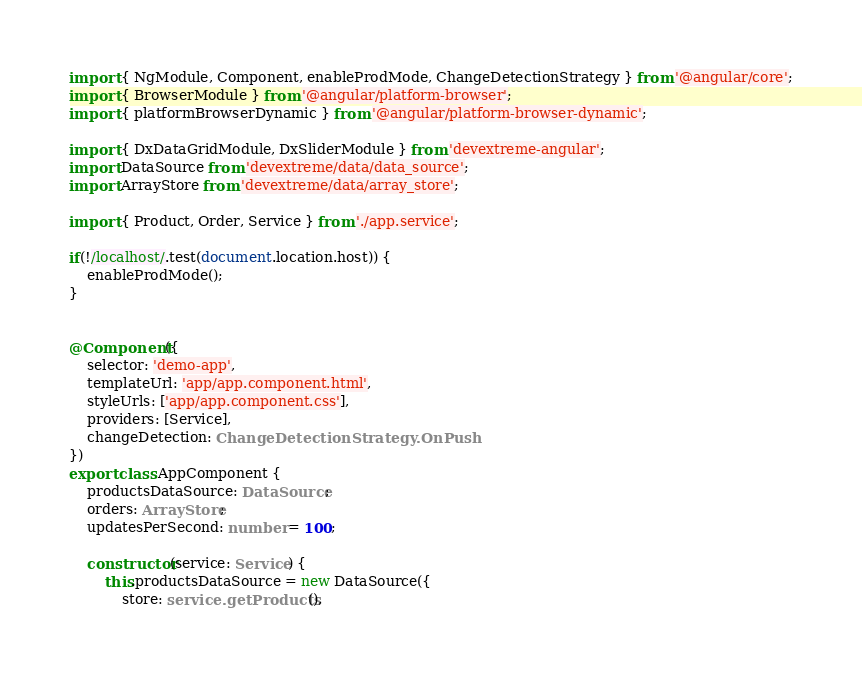Convert code to text. <code><loc_0><loc_0><loc_500><loc_500><_TypeScript_>import { NgModule, Component, enableProdMode, ChangeDetectionStrategy } from '@angular/core';
import { BrowserModule } from '@angular/platform-browser';
import { platformBrowserDynamic } from '@angular/platform-browser-dynamic';

import { DxDataGridModule, DxSliderModule } from 'devextreme-angular';
import DataSource from 'devextreme/data/data_source';
import ArrayStore from 'devextreme/data/array_store';

import { Product, Order, Service } from './app.service';

if(!/localhost/.test(document.location.host)) {
    enableProdMode();
}


@Component({
    selector: 'demo-app',
    templateUrl: 'app/app.component.html',
    styleUrls: ['app/app.component.css'],
    providers: [Service],
    changeDetection: ChangeDetectionStrategy.OnPush
})
export class AppComponent {
    productsDataSource: DataSource;
    orders: ArrayStore;
    updatesPerSecond: number = 100;

    constructor(service: Service) {
        this.productsDataSource = new DataSource({
            store: service.getProducts(),</code> 